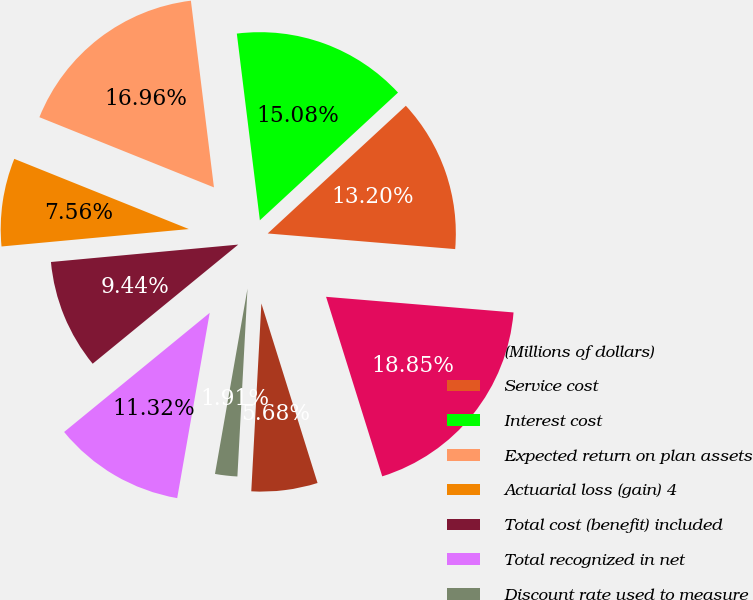Convert chart. <chart><loc_0><loc_0><loc_500><loc_500><pie_chart><fcel>(Millions of dollars)<fcel>Service cost<fcel>Interest cost<fcel>Expected return on plan assets<fcel>Actuarial loss (gain) 4<fcel>Total cost (benefit) included<fcel>Total recognized in net<fcel>Discount rate used to measure<fcel>Expected rate of return on<nl><fcel>18.85%<fcel>13.2%<fcel>15.08%<fcel>16.96%<fcel>7.56%<fcel>9.44%<fcel>11.32%<fcel>1.91%<fcel>5.68%<nl></chart> 